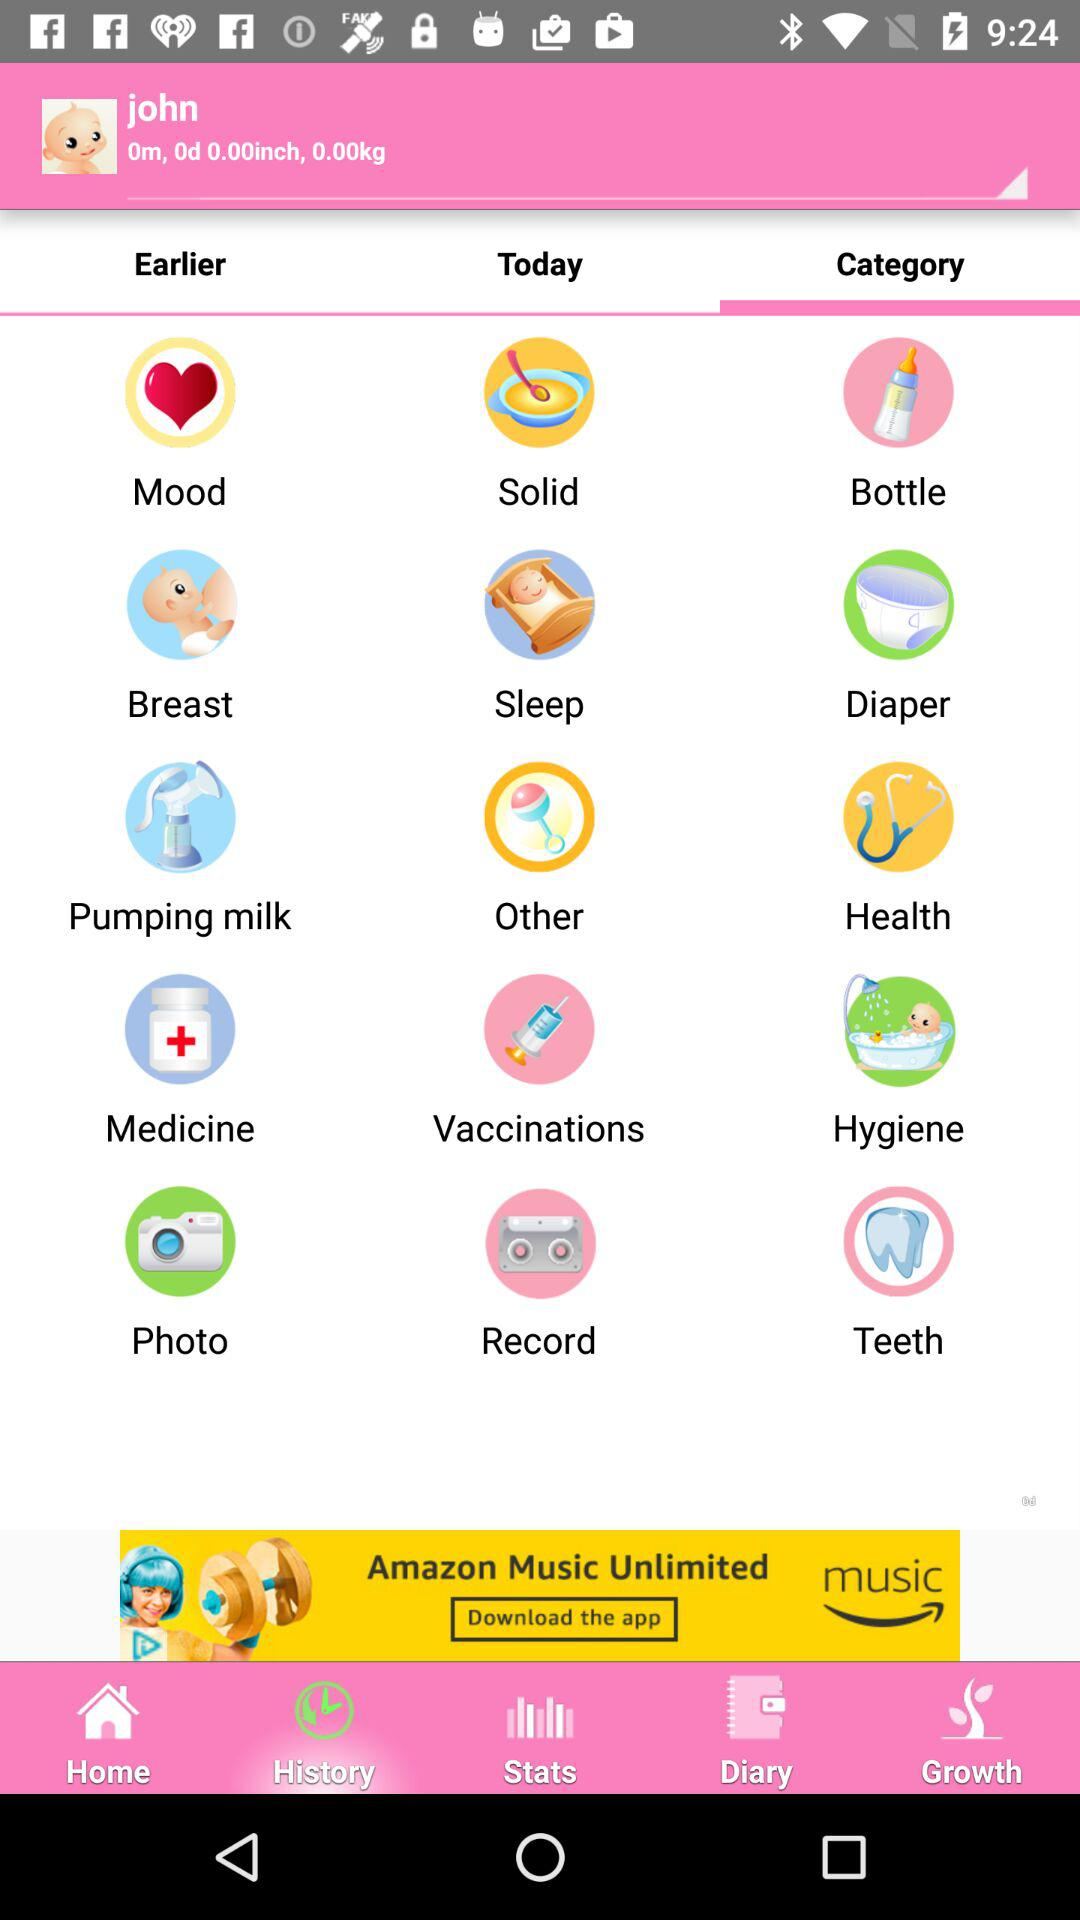What is the age of the baby? The baby is 0 months and 0 days old. 